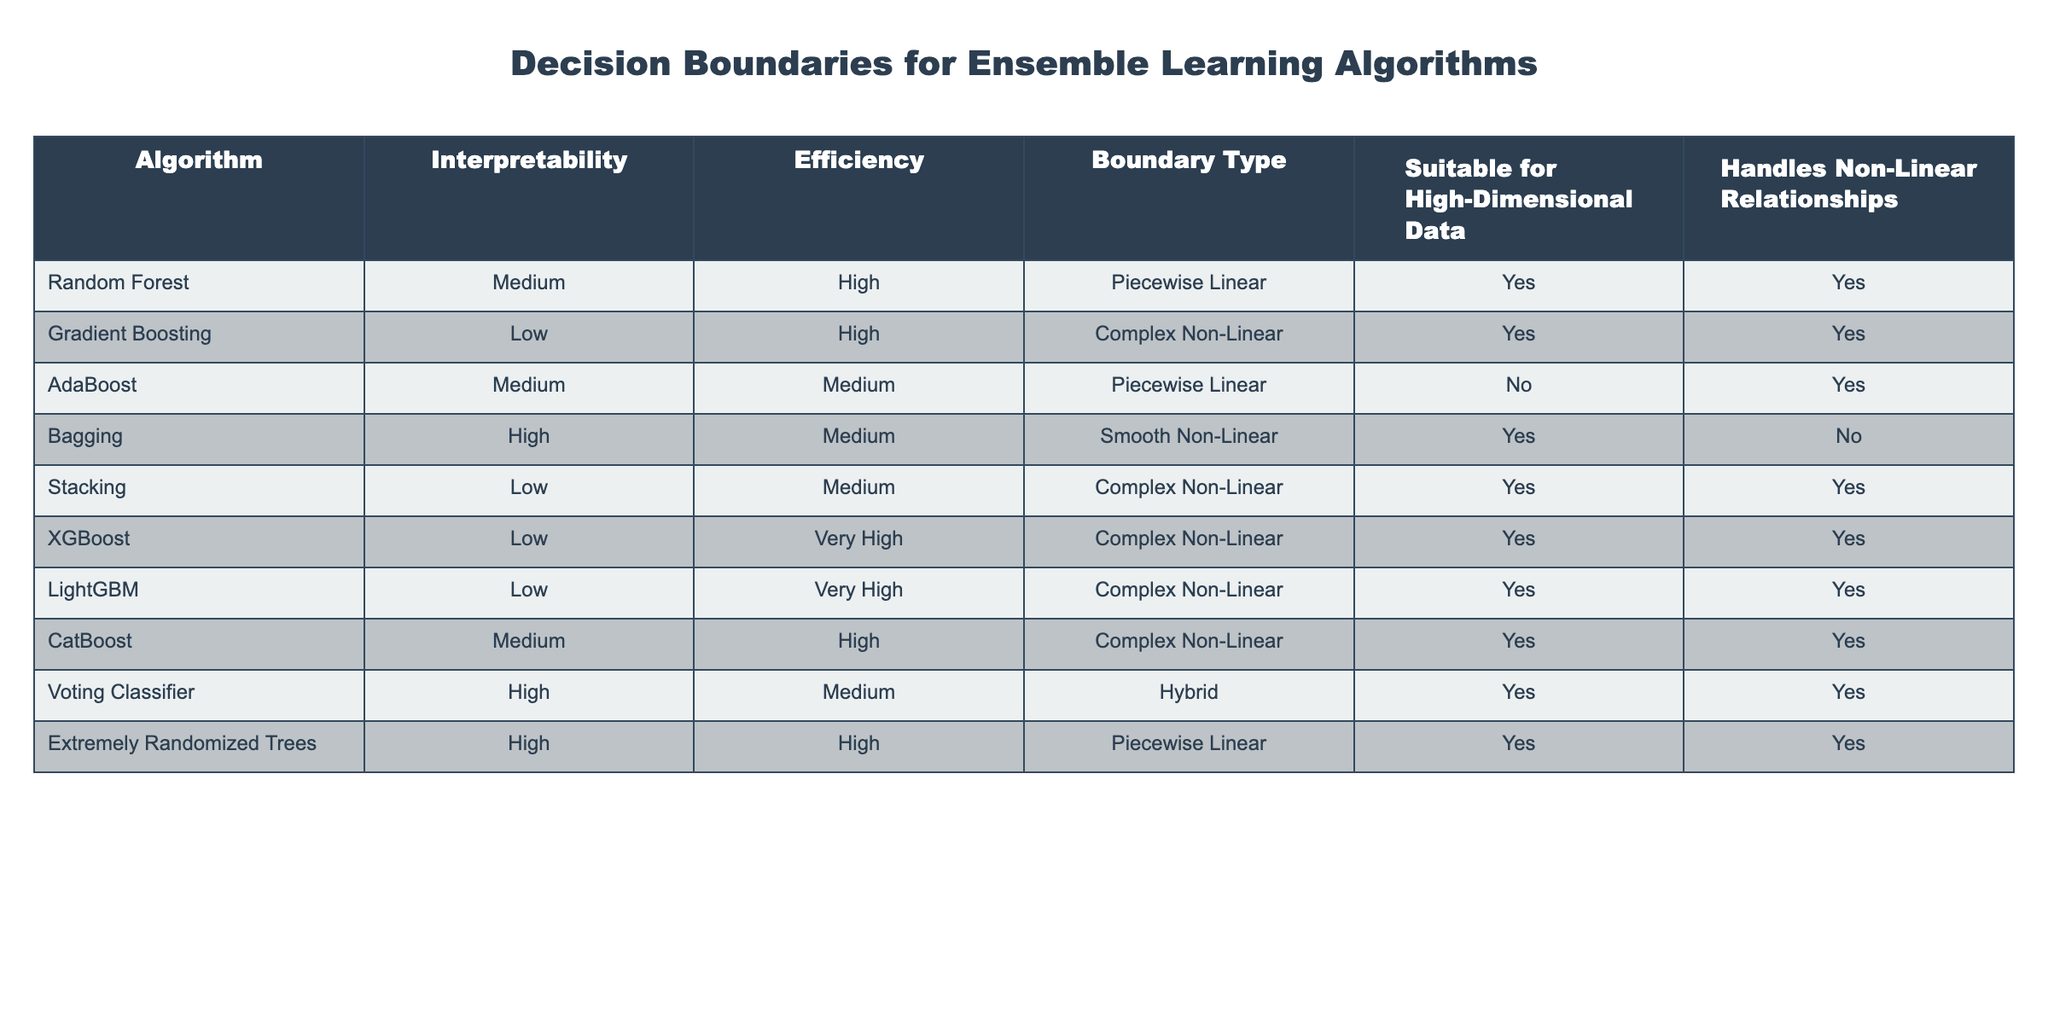What is the interpretability level of the Random Forest algorithm? In the table, the column for interpretability shows that the Random Forest algorithm has a medium interpretability level.
Answer: Medium Which algorithms are suitable for high-dimensional data? By looking at the column "Suitable for High-Dimensional Data," we can see that Random Forest, Gradient Boosting, Bagging, Stacking, XGBoost, LightGBM, CatBoost, Voting Classifier, and Extremely Randomized Trees all meet this criterion.
Answer: Random Forest, Gradient Boosting, Bagging, Stacking, XGBoost, LightGBM, CatBoost, Voting Classifier, Extremely Randomized Trees How many algorithms handle non-linear relationships? The column "Handles Non-Linear Relationships" contains a "Yes" for Random Forest, Gradient Boosting, AdaBoost, Stacking, XGBoost, LightGBM, CatBoost, Voting Classifier, and Extremely Randomized Trees, making a total of 9 algorithms that handle non-linear relationships.
Answer: 9 Is there an algorithm that is both highly efficient and interpretable? The table shows that Bagging and Extremely Randomized Trees are the only algorithms marked as high in efficiency and high in interpretability.
Answer: Yes, Bagging and Extremely Randomized Trees Which algorithm has the highest efficiency? The efficiency level for each algorithm is displayed in the table, with XGBoost and LightGBM listed as "Very High" efficiency, indicating that these are the top performers in terms of efficiency.
Answer: XGBoost and LightGBM What is the boundary type for the Bagging algorithm? The table states that the Bagging algorithm has a "Smooth Non-Linear" boundary type indicated in the corresponding column.
Answer: Smooth Non-Linear Which is the least interpretable algorithm listed in the table? Checking the interpretability column, both Gradient Boosting and Stacking are marked as low, but Gradient Boosting is the first with low interpretability in the list, making it the least interpretable.
Answer: Gradient Boosting How does the efficiency of AdaBoost compare to that of Voting Classifier? From the efficiency column, AdaBoost has medium efficiency while the Voting Classifier has medium efficiency as well, indicating they are equal in this aspect.
Answer: They are equal (both medium efficiency) How many algorithms classify as complex non-linear boundary types? The algorithms with complex non-linear boundaries are Gradient Boosting, Stacking, XGBoost, LightGBM, and CatBoost - five in total.
Answer: 5 